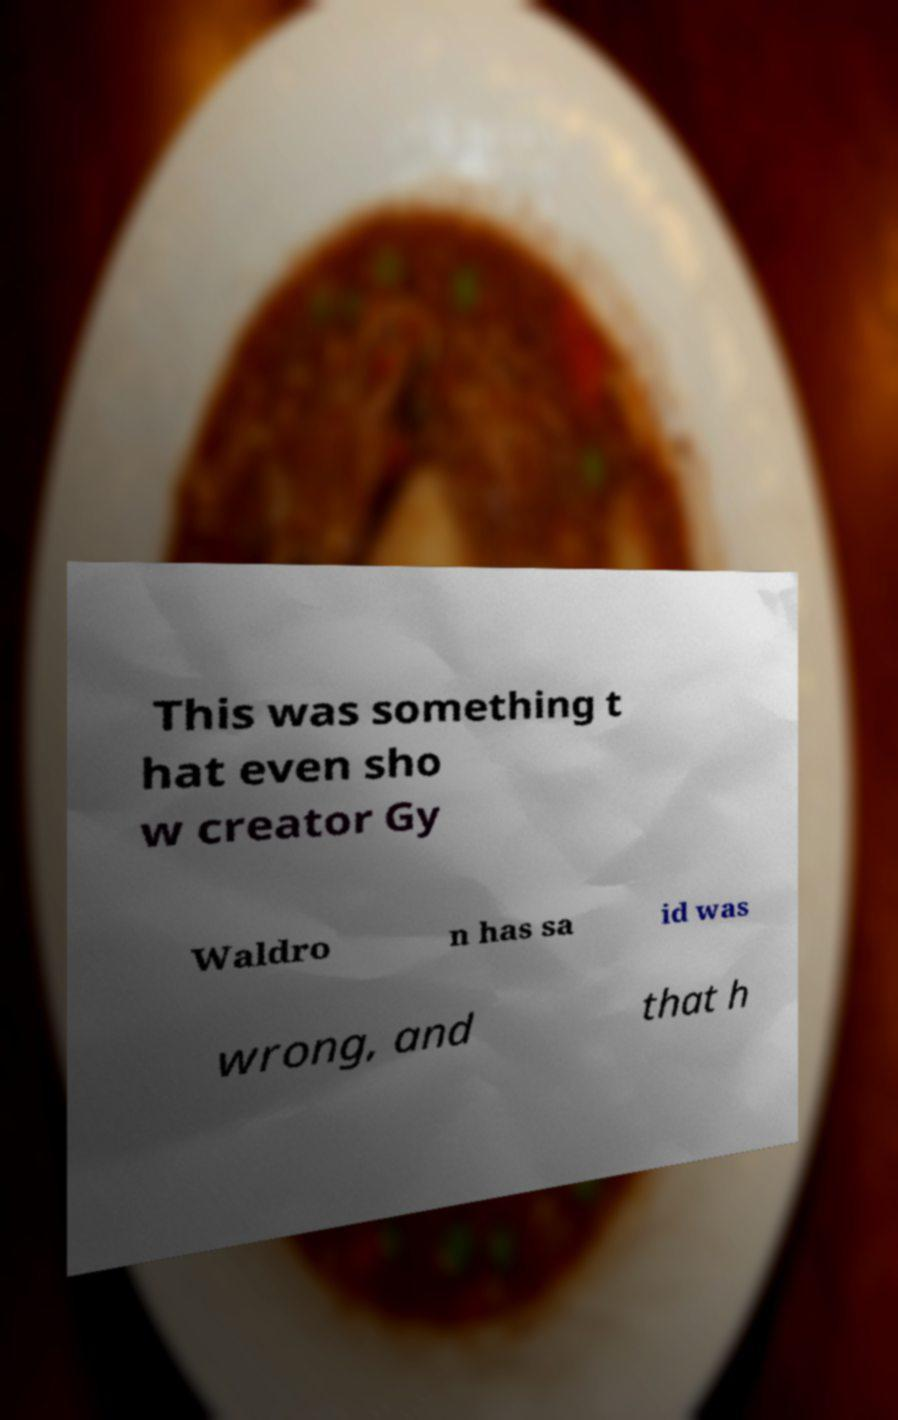Please identify and transcribe the text found in this image. This was something t hat even sho w creator Gy Waldro n has sa id was wrong, and that h 